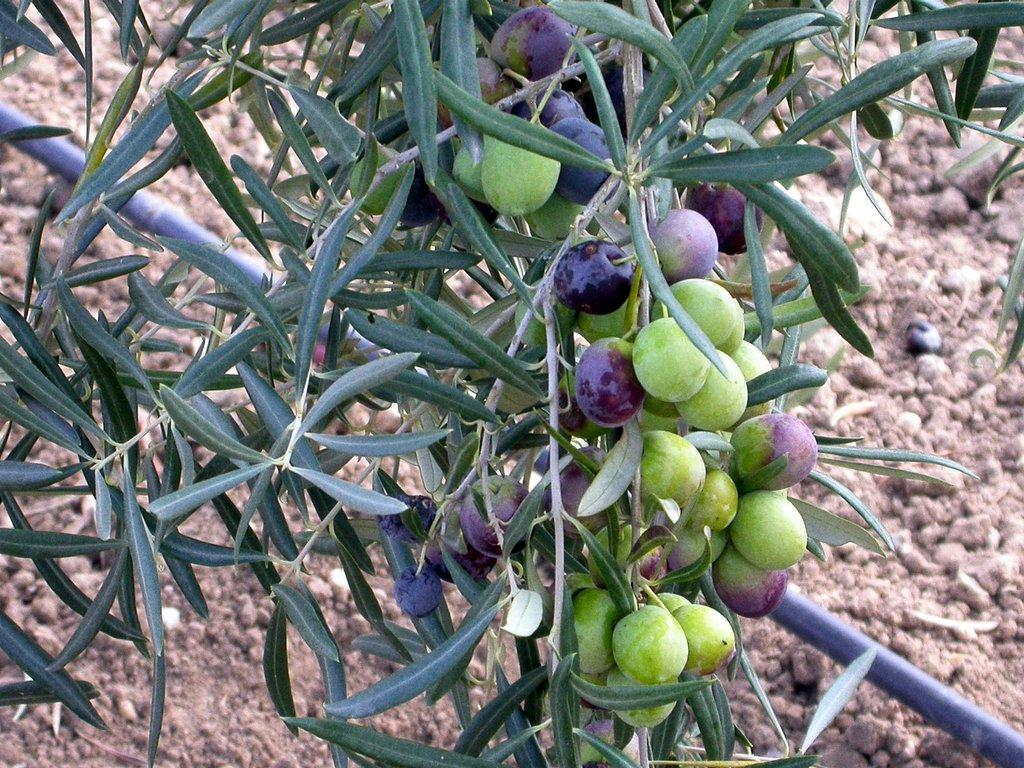What type of plant can be seen in the image? There is a tree in the image. What is on the tree? There is a bunch of fruits on the tree. What can be seen below the tree? The ground is visible in the image. Is there any object on the ground? Yes, there is a stone on the ground. What type of industry is depicted in the image? There is no industry present in the image; it features a tree with fruits and a stone on the ground. 